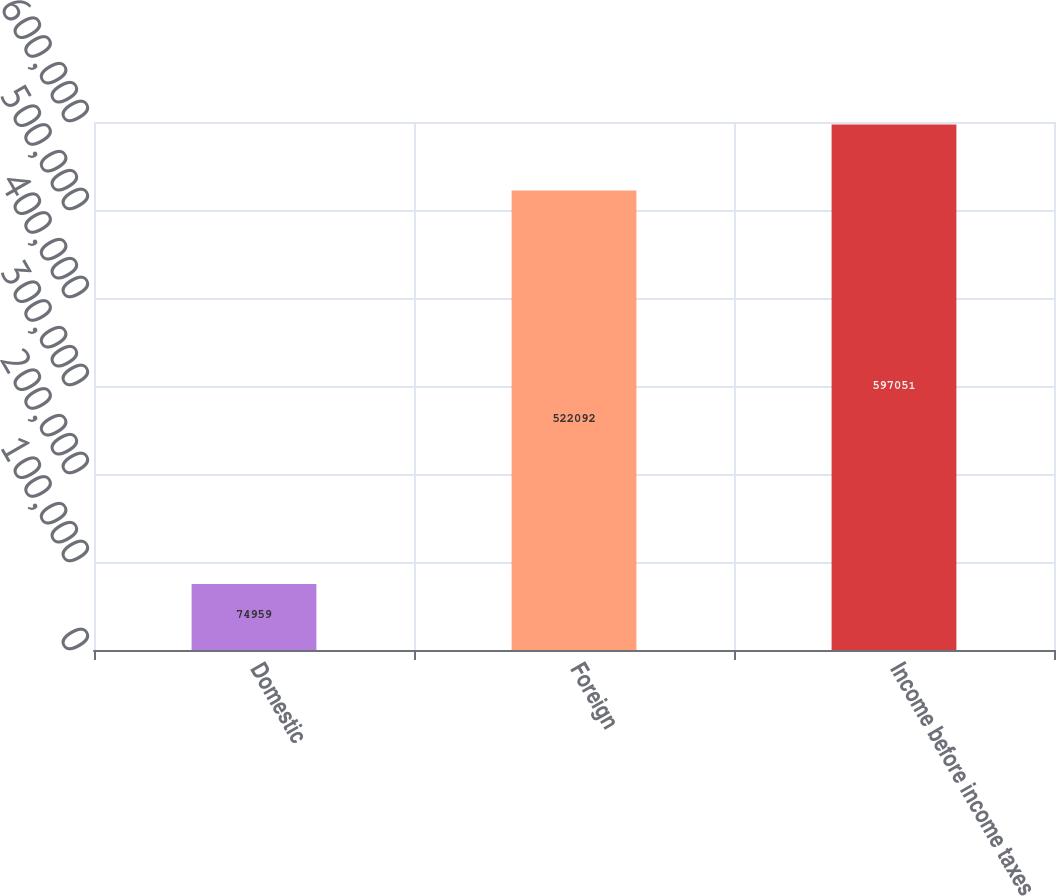<chart> <loc_0><loc_0><loc_500><loc_500><bar_chart><fcel>Domestic<fcel>Foreign<fcel>Income before income taxes<nl><fcel>74959<fcel>522092<fcel>597051<nl></chart> 